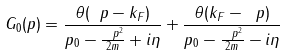Convert formula to latex. <formula><loc_0><loc_0><loc_500><loc_500>G _ { 0 } ( p ) = \frac { \theta ( \ p - k _ { F } ) } { p _ { 0 } - \frac { \ p ^ { 2 } } { 2 m } + i \eta } + \frac { \theta ( k _ { F } - \ p ) } { p _ { 0 } - \frac { \ p ^ { 2 } } { 2 m } - i \eta }</formula> 